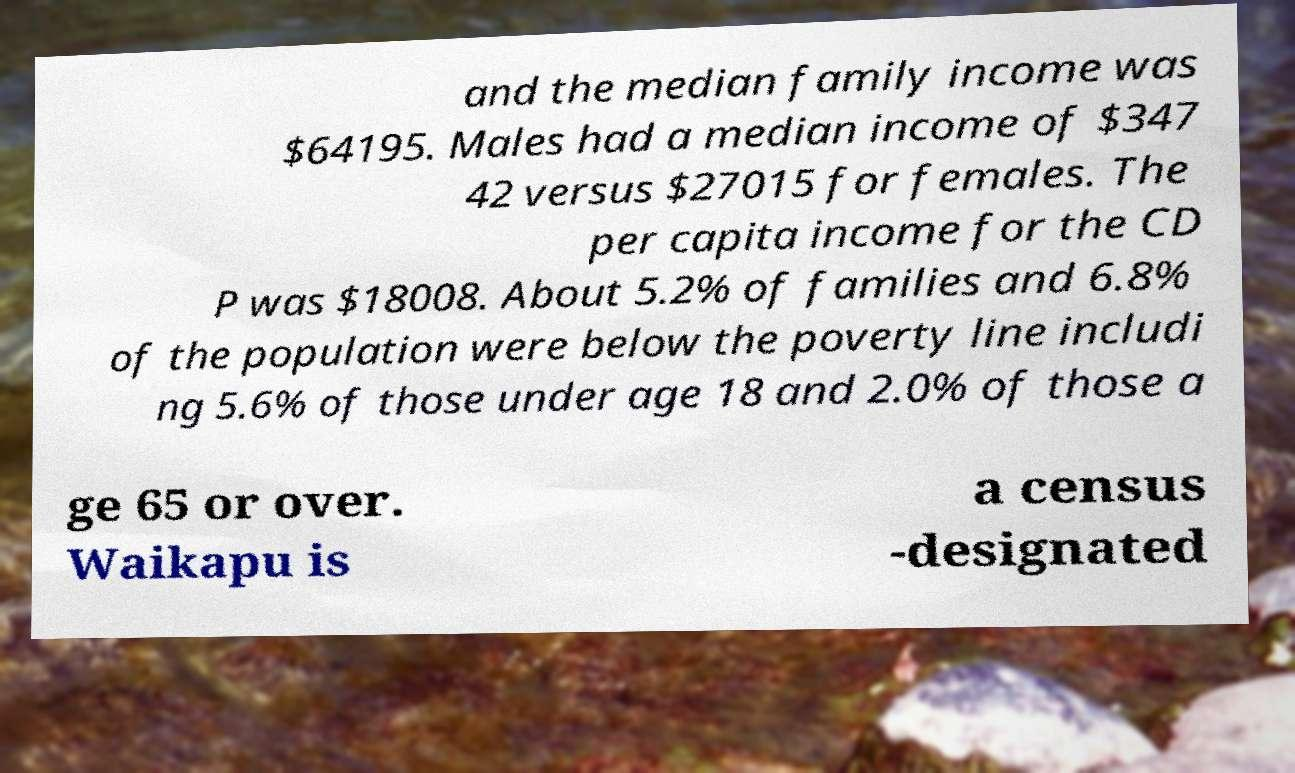What messages or text are displayed in this image? I need them in a readable, typed format. and the median family income was $64195. Males had a median income of $347 42 versus $27015 for females. The per capita income for the CD P was $18008. About 5.2% of families and 6.8% of the population were below the poverty line includi ng 5.6% of those under age 18 and 2.0% of those a ge 65 or over. Waikapu is a census -designated 